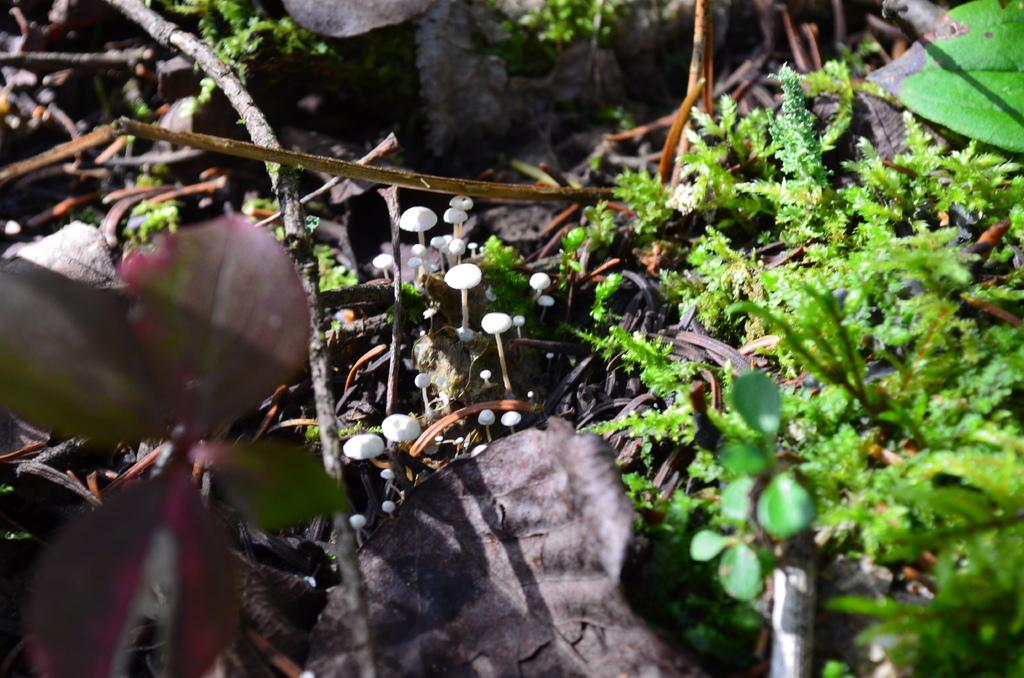What can be seen in the foreground of the picture? There are dry leaves in the foreground of the picture. What is located in the center of the picture? There are mushrooms in the center of the picture. What type of vegetation is on the right side of the picture? There are plants on the right side of the picture. What can be seen at the top of the picture? There are twigs visible at the top of the picture. What type of food is being argued over in the picture? There is no food or argument present in the image; it features dry leaves, mushrooms, plants, and twigs. What does the picture smell like? The picture does not have a smell, as it is a visual representation. 